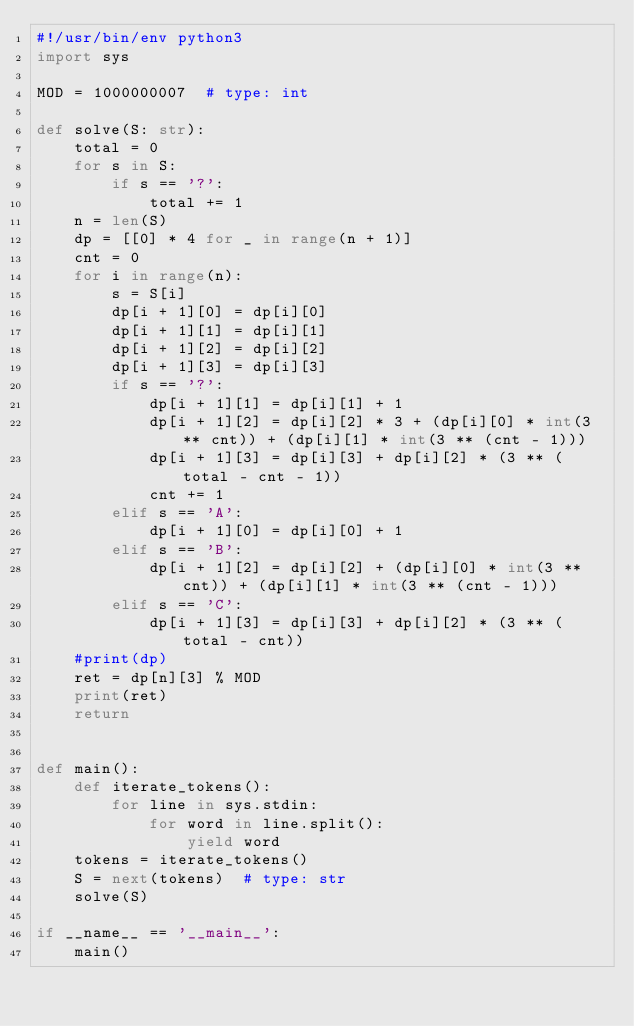Convert code to text. <code><loc_0><loc_0><loc_500><loc_500><_Python_>#!/usr/bin/env python3
import sys

MOD = 1000000007  # type: int

def solve(S: str):
    total = 0
    for s in S:
        if s == '?':
            total += 1
    n = len(S)
    dp = [[0] * 4 for _ in range(n + 1)]
    cnt = 0
    for i in range(n):
        s = S[i]
        dp[i + 1][0] = dp[i][0]
        dp[i + 1][1] = dp[i][1]
        dp[i + 1][2] = dp[i][2]
        dp[i + 1][3] = dp[i][3]
        if s == '?':
            dp[i + 1][1] = dp[i][1] + 1
            dp[i + 1][2] = dp[i][2] * 3 + (dp[i][0] * int(3 ** cnt)) + (dp[i][1] * int(3 ** (cnt - 1)))
            dp[i + 1][3] = dp[i][3] + dp[i][2] * (3 ** (total - cnt - 1))
            cnt += 1
        elif s == 'A':
            dp[i + 1][0] = dp[i][0] + 1
        elif s == 'B':
            dp[i + 1][2] = dp[i][2] + (dp[i][0] * int(3 ** cnt)) + (dp[i][1] * int(3 ** (cnt - 1)))
        elif s == 'C':
            dp[i + 1][3] = dp[i][3] + dp[i][2] * (3 ** (total - cnt))
    #print(dp)
    ret = dp[n][3] % MOD
    print(ret)
    return


def main():
    def iterate_tokens():
        for line in sys.stdin:
            for word in line.split():
                yield word
    tokens = iterate_tokens()
    S = next(tokens)  # type: str
    solve(S)

if __name__ == '__main__':
    main()
</code> 